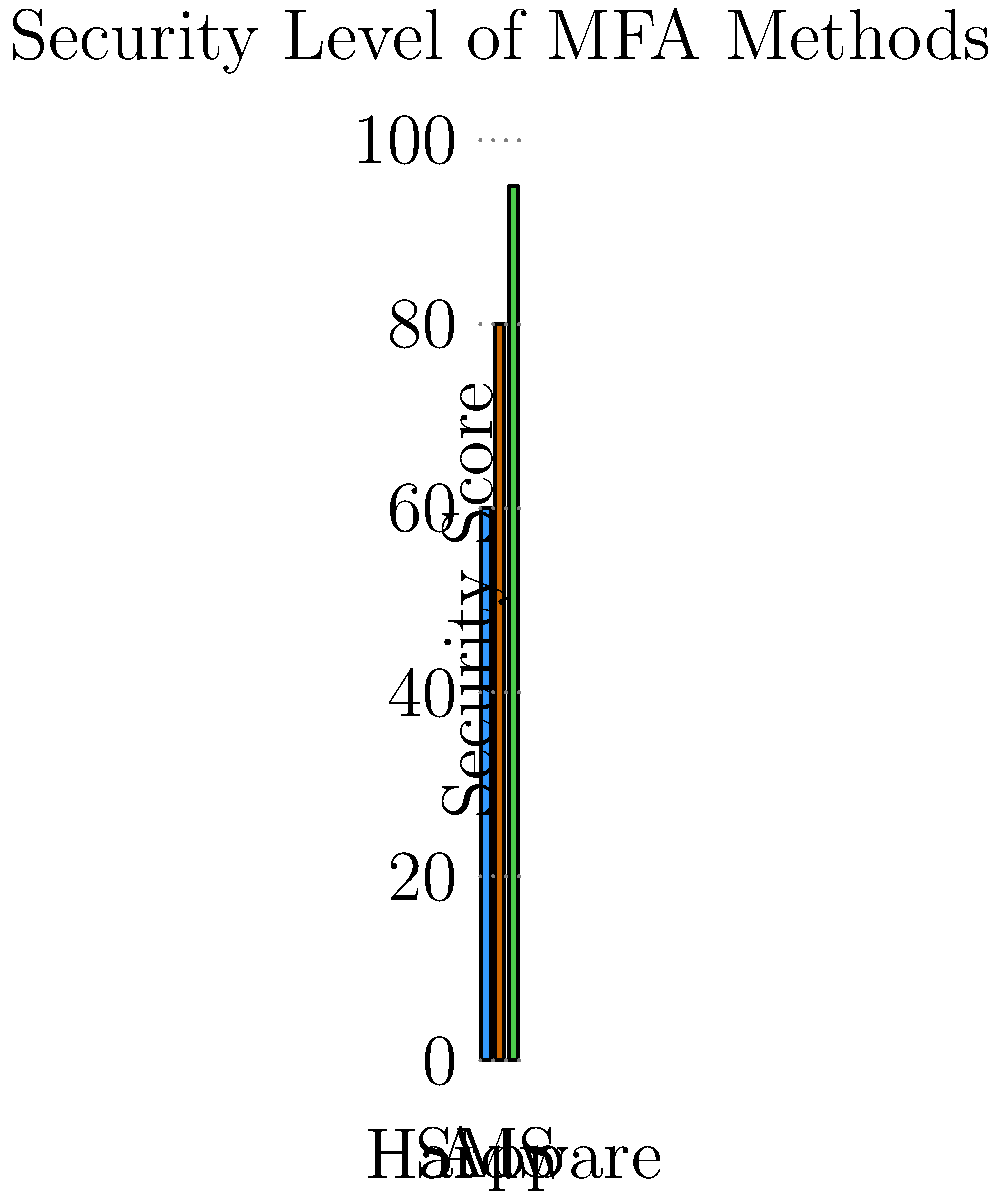As a human resources manager concerned about phishing scams, you're evaluating multi-factor authentication (MFA) methods. Based on the graph, which MFA method provides the highest level of security for your company's sensitive data? To determine the most secure MFA method, let's analyze the graph step-by-step:

1. The graph shows three MFA methods: SMS, App, and Hardware.
2. The y-axis represents the security score, ranging from 0 to 100.
3. For each method, we need to identify its security score:
   - SMS: The bar reaches approximately 60 on the y-axis.
   - App: The bar reaches approximately 80 on the y-axis.
   - Hardware: The bar reaches approximately 95 on the y-axis.
4. Comparing these scores:
   95 (Hardware) > 80 (App) > 60 (SMS)
5. Therefore, the Hardware MFA method provides the highest level of security.

In the context of protecting against phishing scams, hardware-based MFA (such as security keys) offers the strongest protection. This is because hardware tokens are not susceptible to common phishing tactics that can compromise SMS or app-based authentication methods.
Answer: Hardware MFA 